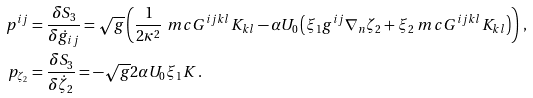Convert formula to latex. <formula><loc_0><loc_0><loc_500><loc_500>p ^ { i j } & = \frac { \delta S _ { 3 } } { \delta \dot { g } _ { i j } } = \sqrt { g } \left ( \frac { 1 } { 2 \kappa ^ { 2 } } \ m c { G } ^ { i j k l } K _ { k l } - \alpha U _ { 0 } \left ( \xi _ { 1 } g ^ { i j } \nabla _ { n } \zeta _ { 2 } + \xi _ { 2 } \ m c { G } ^ { i j k l } K _ { k l } \right ) \right ) \, , \\ p _ { \zeta _ { 2 } } & = \frac { \delta S _ { 3 } } { \delta \dot { \zeta } _ { 2 } } = - \sqrt { g } 2 \alpha U _ { 0 } \xi _ { 1 } K \, .</formula> 